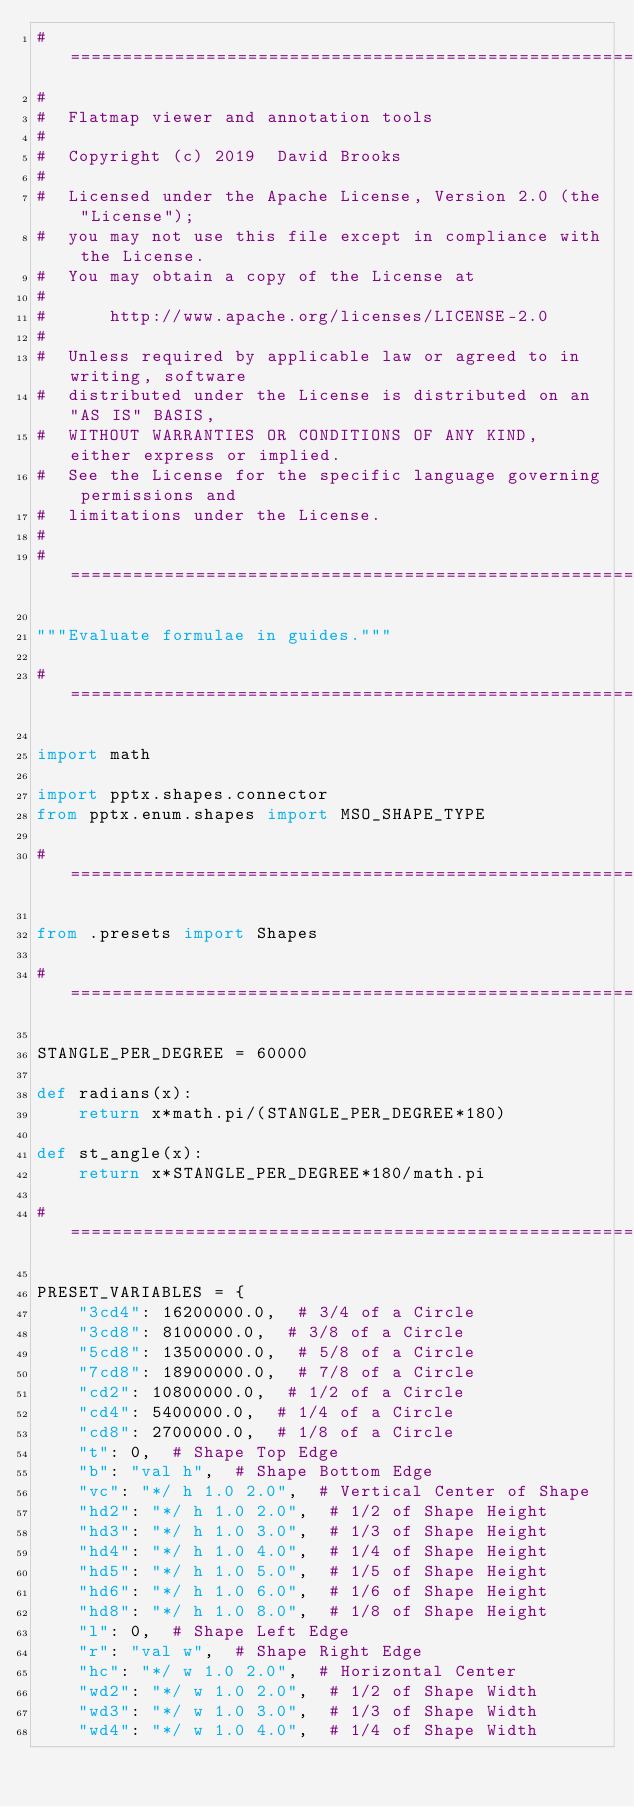<code> <loc_0><loc_0><loc_500><loc_500><_Python_>#===============================================================================
#
#  Flatmap viewer and annotation tools
#
#  Copyright (c) 2019  David Brooks
#
#  Licensed under the Apache License, Version 2.0 (the "License");
#  you may not use this file except in compliance with the License.
#  You may obtain a copy of the License at
#
#      http://www.apache.org/licenses/LICENSE-2.0
#
#  Unless required by applicable law or agreed to in writing, software
#  distributed under the License is distributed on an "AS IS" BASIS,
#  WITHOUT WARRANTIES OR CONDITIONS OF ANY KIND, either express or implied.
#  See the License for the specific language governing permissions and
#  limitations under the License.
#
#===============================================================================

"""Evaluate formulae in guides."""

#===============================================================================

import math

import pptx.shapes.connector
from pptx.enum.shapes import MSO_SHAPE_TYPE

#===============================================================================

from .presets import Shapes

#===============================================================================

STANGLE_PER_DEGREE = 60000

def radians(x):
    return x*math.pi/(STANGLE_PER_DEGREE*180)

def st_angle(x):
    return x*STANGLE_PER_DEGREE*180/math.pi

#===============================================================================

PRESET_VARIABLES = {
    "3cd4": 16200000.0,  # 3/4 of a Circle
    "3cd8": 8100000.0,  # 3/8 of a Circle
    "5cd8": 13500000.0,  # 5/8 of a Circle
    "7cd8": 18900000.0,  # 7/8 of a Circle
    "cd2": 10800000.0,  # 1/2 of a Circle
    "cd4": 5400000.0,  # 1/4 of a Circle
    "cd8": 2700000.0,  # 1/8 of a Circle
    "t": 0,  # Shape Top Edge
    "b": "val h",  # Shape Bottom Edge
    "vc": "*/ h 1.0 2.0",  # Vertical Center of Shape
    "hd2": "*/ h 1.0 2.0",  # 1/2 of Shape Height
    "hd3": "*/ h 1.0 3.0",  # 1/3 of Shape Height
    "hd4": "*/ h 1.0 4.0",  # 1/4 of Shape Height
    "hd5": "*/ h 1.0 5.0",  # 1/5 of Shape Height
    "hd6": "*/ h 1.0 6.0",  # 1/6 of Shape Height
    "hd8": "*/ h 1.0 8.0",  # 1/8 of Shape Height
    "l": 0,  # Shape Left Edge
    "r": "val w",  # Shape Right Edge
    "hc": "*/ w 1.0 2.0",  # Horizontal Center
    "wd2": "*/ w 1.0 2.0",  # 1/2 of Shape Width
    "wd3": "*/ w 1.0 3.0",  # 1/3 of Shape Width
    "wd4": "*/ w 1.0 4.0",  # 1/4 of Shape Width</code> 